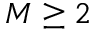Convert formula to latex. <formula><loc_0><loc_0><loc_500><loc_500>M \geq 2</formula> 